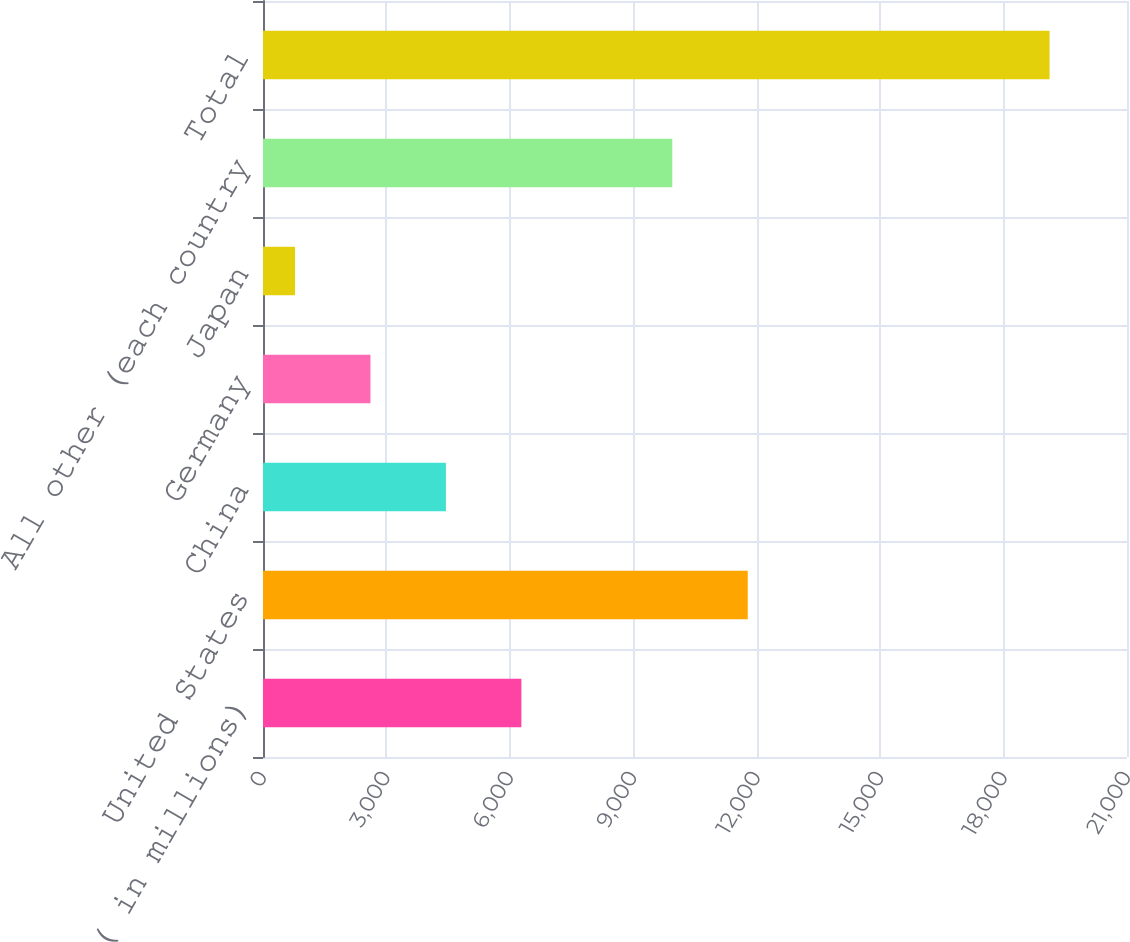Convert chart. <chart><loc_0><loc_0><loc_500><loc_500><bar_chart><fcel>( in millions)<fcel>United States<fcel>China<fcel>Germany<fcel>Japan<fcel>All other (each country<fcel>Total<nl><fcel>6279.79<fcel>11781.9<fcel>4445.76<fcel>2611.73<fcel>777.7<fcel>9947.85<fcel>19118<nl></chart> 